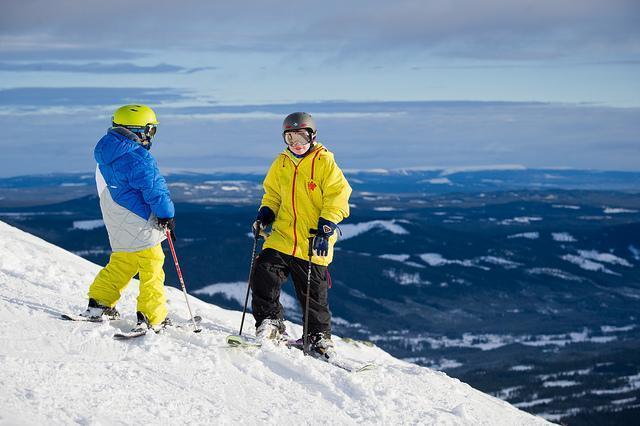How many people can you see?
Give a very brief answer. 2. 